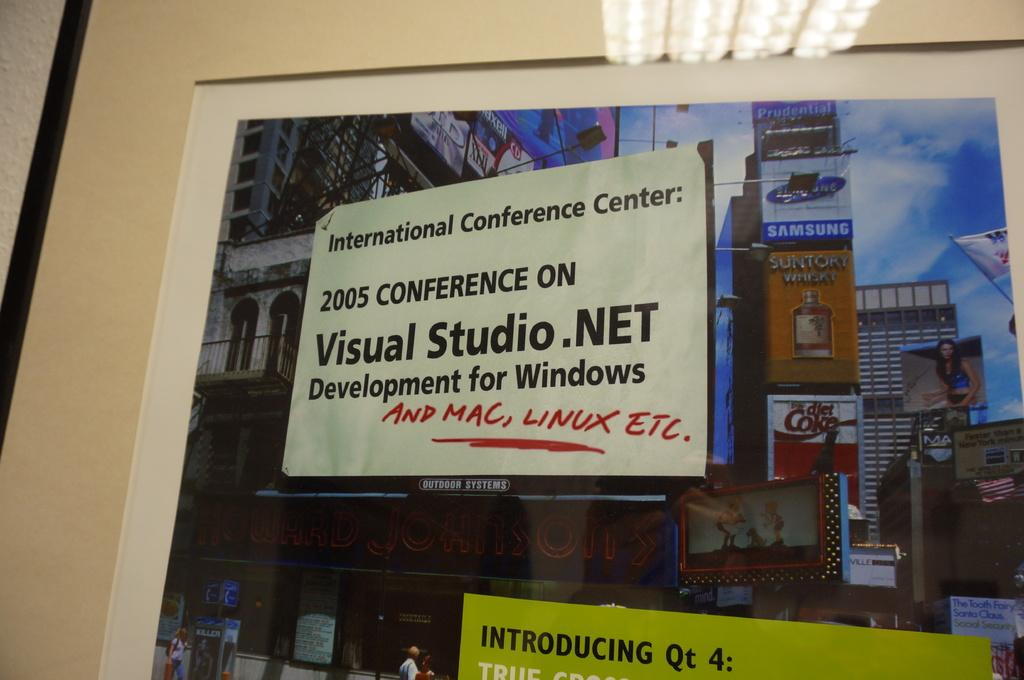<image>
Create a compact narrative representing the image presented. A photo of several billboards including one for Diet Coke and Samsung 